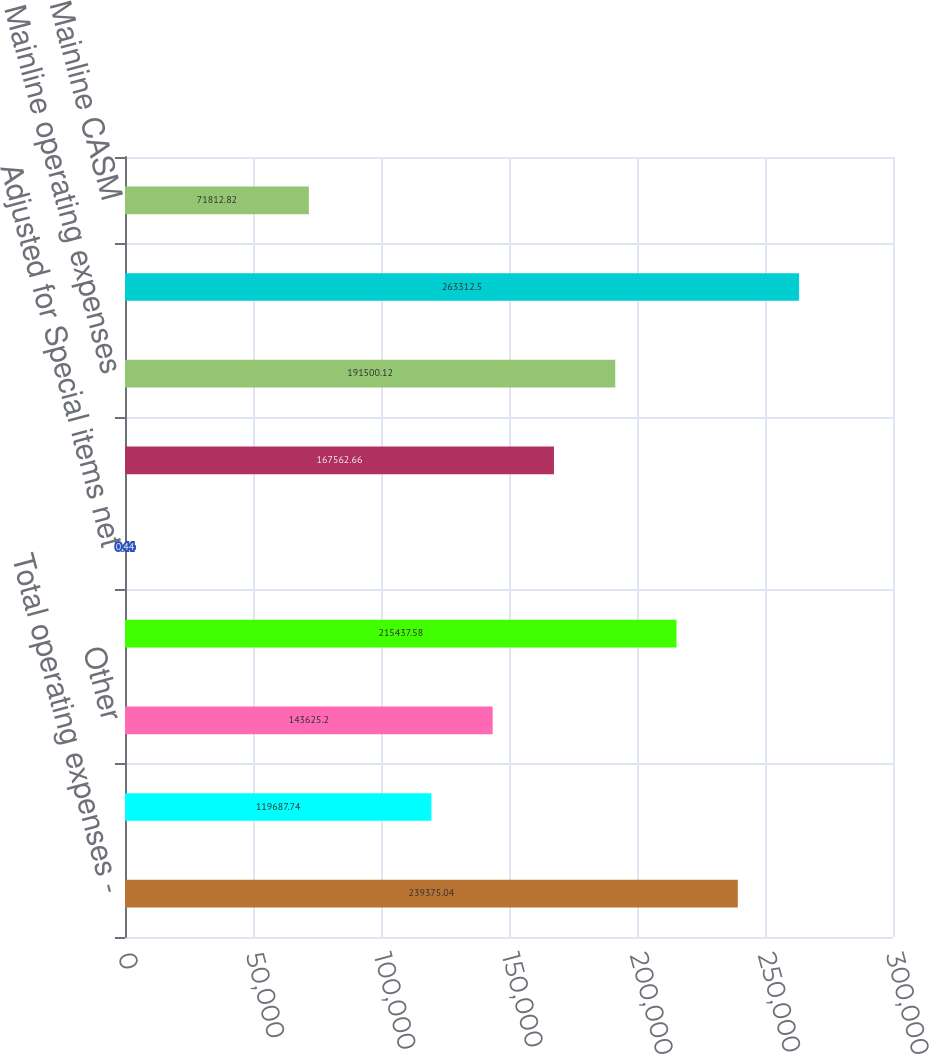Convert chart. <chart><loc_0><loc_0><loc_500><loc_500><bar_chart><fcel>Total operating expenses -<fcel>Fuel and related taxes<fcel>Other<fcel>Total mainline operating<fcel>Adjusted for Special items net<fcel>Adjusted for Aircraft fuel and<fcel>Mainline operating expenses<fcel>Available Seat Miles (ASM)<fcel>Mainline CASM<nl><fcel>239375<fcel>119688<fcel>143625<fcel>215438<fcel>0.44<fcel>167563<fcel>191500<fcel>263312<fcel>71812.8<nl></chart> 